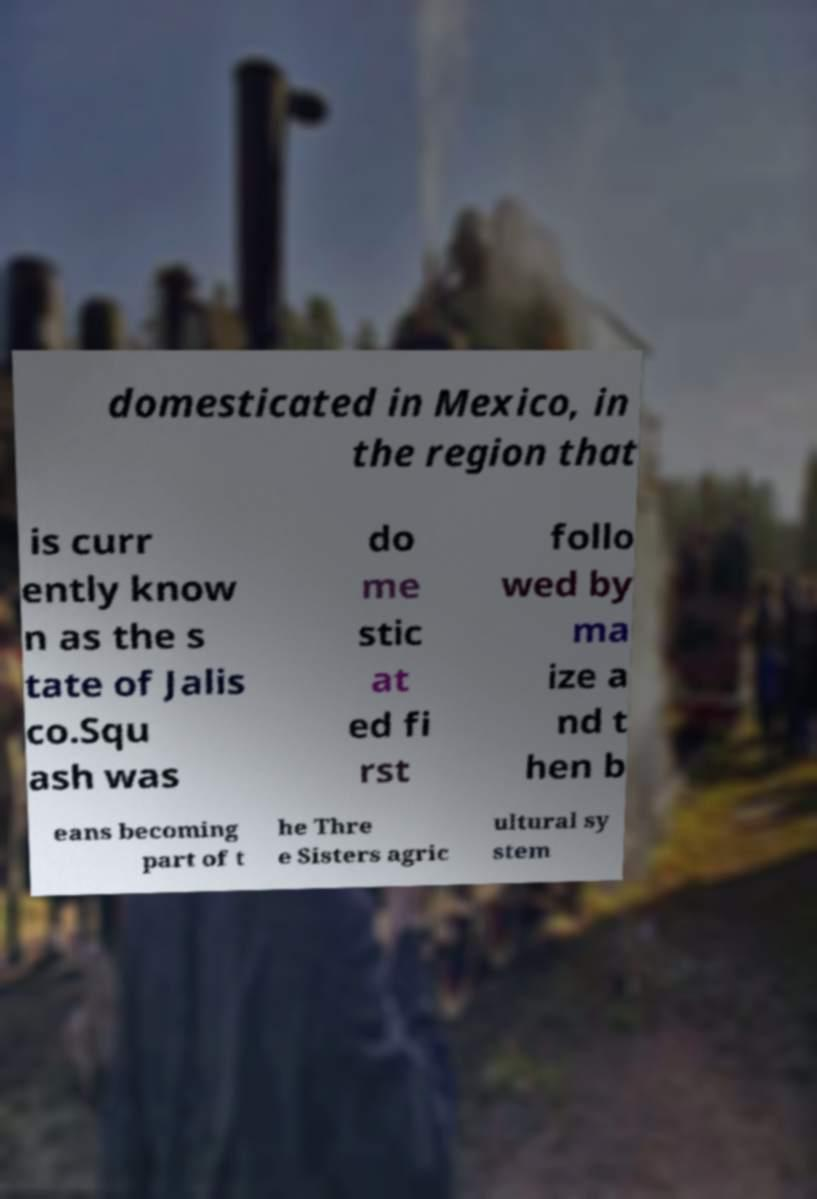Could you extract and type out the text from this image? domesticated in Mexico, in the region that is curr ently know n as the s tate of Jalis co.Squ ash was do me stic at ed fi rst follo wed by ma ize a nd t hen b eans becoming part of t he Thre e Sisters agric ultural sy stem 